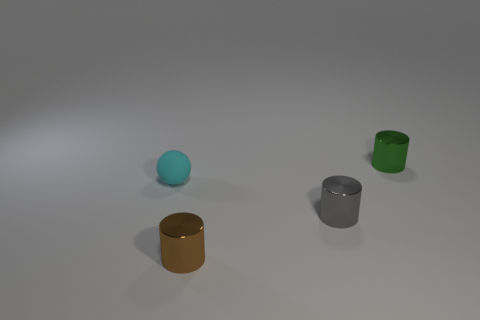Among the objects presented, which one appears to have the most reflective surface? The object with the most reflective surface in the image is the silver cylinder. Its surface reflects the light strongly, highlighting its metallic properties and differentiating it from the other objects. 